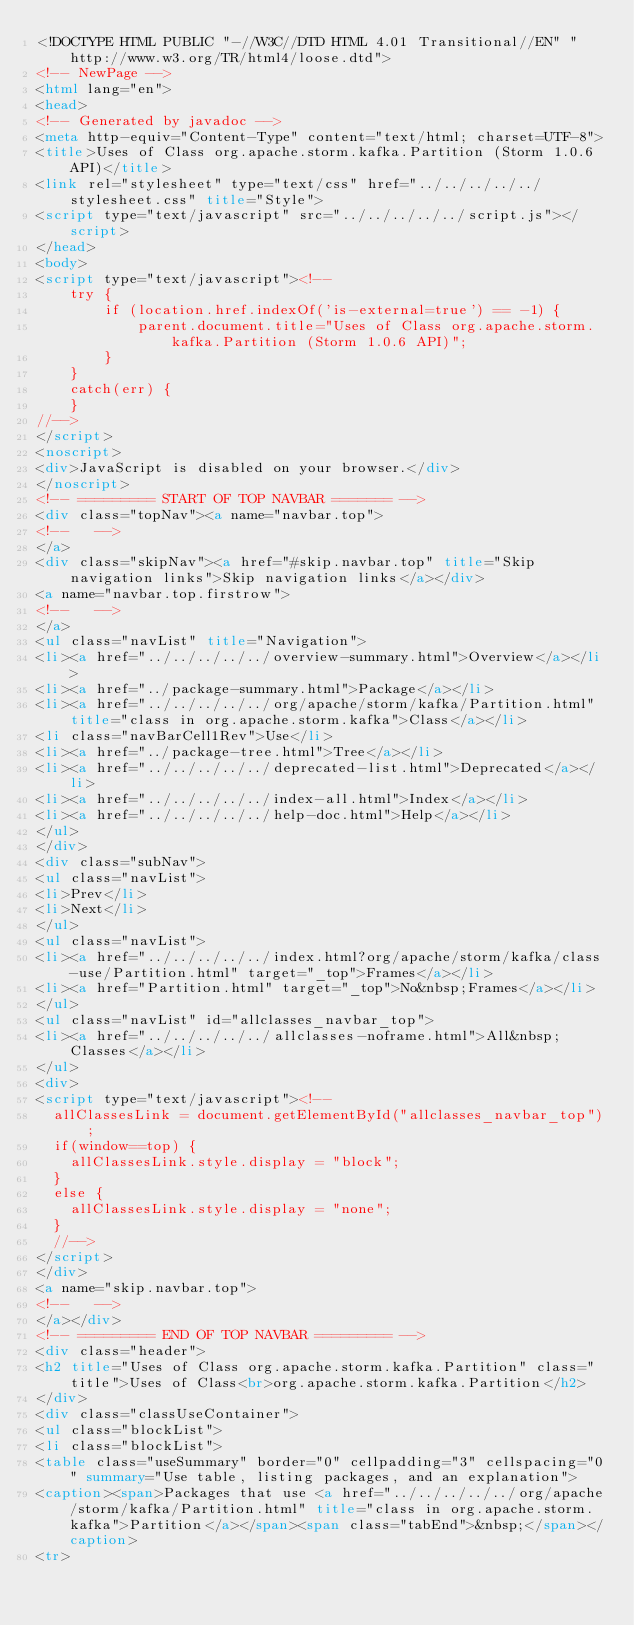<code> <loc_0><loc_0><loc_500><loc_500><_HTML_><!DOCTYPE HTML PUBLIC "-//W3C//DTD HTML 4.01 Transitional//EN" "http://www.w3.org/TR/html4/loose.dtd">
<!-- NewPage -->
<html lang="en">
<head>
<!-- Generated by javadoc -->
<meta http-equiv="Content-Type" content="text/html; charset=UTF-8">
<title>Uses of Class org.apache.storm.kafka.Partition (Storm 1.0.6 API)</title>
<link rel="stylesheet" type="text/css" href="../../../../../stylesheet.css" title="Style">
<script type="text/javascript" src="../../../../../script.js"></script>
</head>
<body>
<script type="text/javascript"><!--
    try {
        if (location.href.indexOf('is-external=true') == -1) {
            parent.document.title="Uses of Class org.apache.storm.kafka.Partition (Storm 1.0.6 API)";
        }
    }
    catch(err) {
    }
//-->
</script>
<noscript>
<div>JavaScript is disabled on your browser.</div>
</noscript>
<!-- ========= START OF TOP NAVBAR ======= -->
<div class="topNav"><a name="navbar.top">
<!--   -->
</a>
<div class="skipNav"><a href="#skip.navbar.top" title="Skip navigation links">Skip navigation links</a></div>
<a name="navbar.top.firstrow">
<!--   -->
</a>
<ul class="navList" title="Navigation">
<li><a href="../../../../../overview-summary.html">Overview</a></li>
<li><a href="../package-summary.html">Package</a></li>
<li><a href="../../../../../org/apache/storm/kafka/Partition.html" title="class in org.apache.storm.kafka">Class</a></li>
<li class="navBarCell1Rev">Use</li>
<li><a href="../package-tree.html">Tree</a></li>
<li><a href="../../../../../deprecated-list.html">Deprecated</a></li>
<li><a href="../../../../../index-all.html">Index</a></li>
<li><a href="../../../../../help-doc.html">Help</a></li>
</ul>
</div>
<div class="subNav">
<ul class="navList">
<li>Prev</li>
<li>Next</li>
</ul>
<ul class="navList">
<li><a href="../../../../../index.html?org/apache/storm/kafka/class-use/Partition.html" target="_top">Frames</a></li>
<li><a href="Partition.html" target="_top">No&nbsp;Frames</a></li>
</ul>
<ul class="navList" id="allclasses_navbar_top">
<li><a href="../../../../../allclasses-noframe.html">All&nbsp;Classes</a></li>
</ul>
<div>
<script type="text/javascript"><!--
  allClassesLink = document.getElementById("allclasses_navbar_top");
  if(window==top) {
    allClassesLink.style.display = "block";
  }
  else {
    allClassesLink.style.display = "none";
  }
  //-->
</script>
</div>
<a name="skip.navbar.top">
<!--   -->
</a></div>
<!-- ========= END OF TOP NAVBAR ========= -->
<div class="header">
<h2 title="Uses of Class org.apache.storm.kafka.Partition" class="title">Uses of Class<br>org.apache.storm.kafka.Partition</h2>
</div>
<div class="classUseContainer">
<ul class="blockList">
<li class="blockList">
<table class="useSummary" border="0" cellpadding="3" cellspacing="0" summary="Use table, listing packages, and an explanation">
<caption><span>Packages that use <a href="../../../../../org/apache/storm/kafka/Partition.html" title="class in org.apache.storm.kafka">Partition</a></span><span class="tabEnd">&nbsp;</span></caption>
<tr></code> 